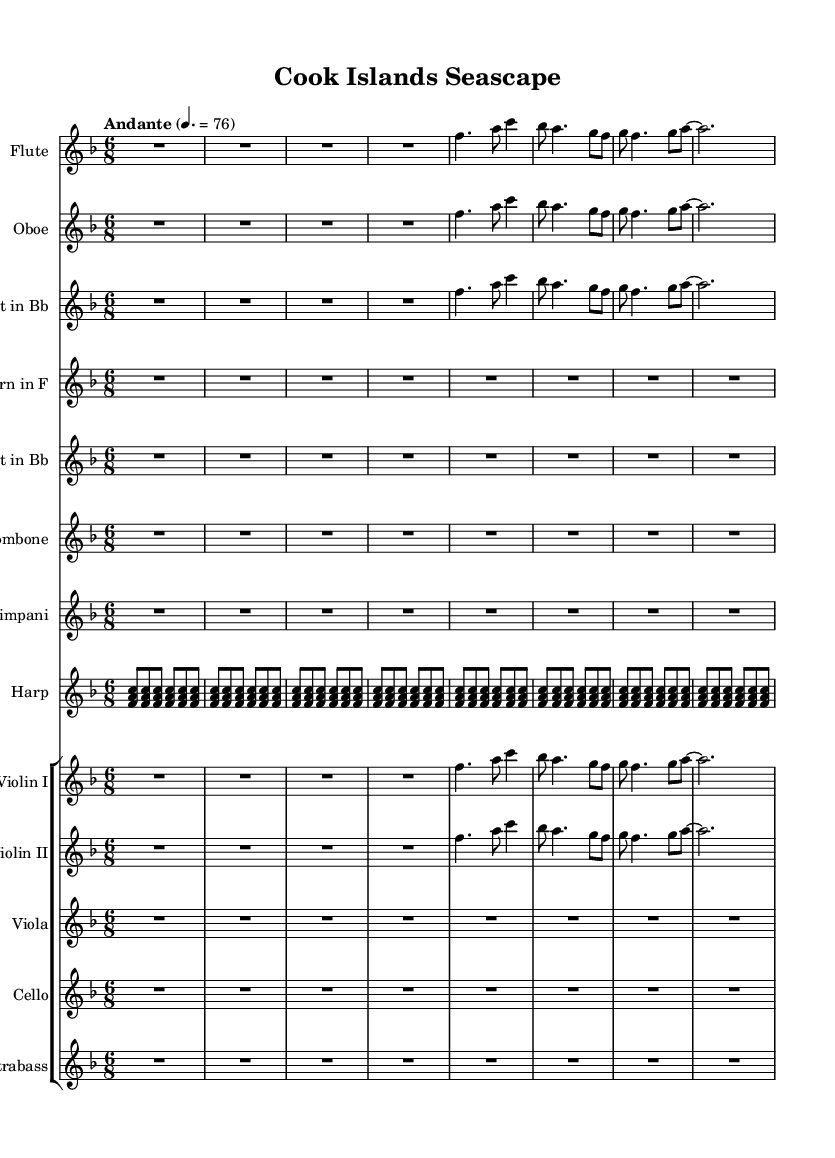What is the key signature of this music? The key signature is F major, which has one flat (B flat). This is indicated by the presence of the flat sign at the beginning of the staff.
Answer: F major What is the time signature of this piece? The time signature is 6/8, which means there are six eighth notes in each measure. This is indicated by the notation at the beginning of the staff.
Answer: 6/8 What is the tempo marking for this piece? The tempo marking is "Andante," which indicates a moderate pace for the music. This can be found written above the staff in the tempo indication section.
Answer: Andante How many instruments are included in this symphony? There are ten instruments included in this symphony, as seen from the list of staves provided in the score. Counting each separate instrument staff gives us this total.
Answer: Ten Which instruments are featured in the woodwind section? The woodwind section includes Flute, Oboe, and Clarinet, as shown by the individual staves that specify these instruments at the top. This directly indicates the woodwind instrumentation.
Answer: Flute, Oboe, Clarinet What is the primary musical theme reflected in the flute and violin parts? The primary musical theme in the flute and violin parts is the same melodic line, as they are written with identical notes in this segment. This reflects the thematic unity in the orchestration.
Answer: Same How does the harp part contribute to the overall texture of the piece? The harp part provides a consistent arpeggiated accompaniment pattern, which enriches the harmonic texture and supports the melody played by the other instruments. This is shown through repeated patterns of chords in the score.
Answer: Arpeggiated accompaniment 